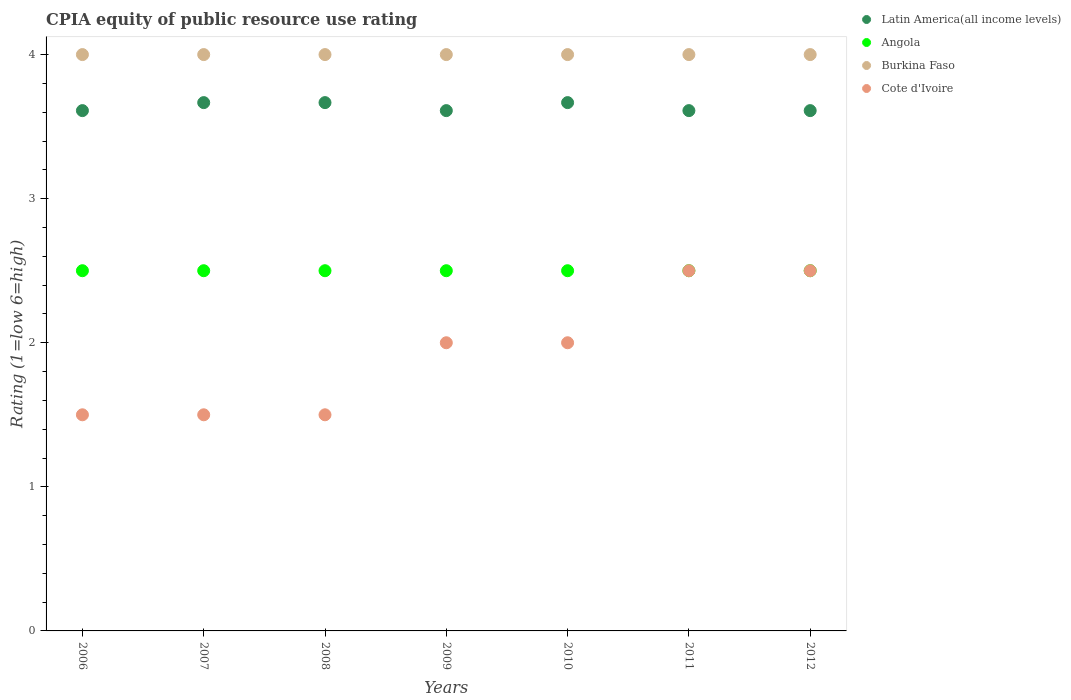Is the number of dotlines equal to the number of legend labels?
Ensure brevity in your answer.  Yes. What is the CPIA rating in Burkina Faso in 2007?
Offer a terse response. 4. Across all years, what is the maximum CPIA rating in Burkina Faso?
Your answer should be very brief. 4. Across all years, what is the minimum CPIA rating in Angola?
Offer a very short reply. 2.5. In which year was the CPIA rating in Angola maximum?
Give a very brief answer. 2006. In which year was the CPIA rating in Cote d'Ivoire minimum?
Give a very brief answer. 2006. What is the total CPIA rating in Burkina Faso in the graph?
Offer a very short reply. 28. What is the difference between the CPIA rating in Latin America(all income levels) in 2009 and that in 2010?
Ensure brevity in your answer.  -0.06. What is the difference between the CPIA rating in Cote d'Ivoire in 2011 and the CPIA rating in Latin America(all income levels) in 2008?
Offer a terse response. -1.17. What is the average CPIA rating in Cote d'Ivoire per year?
Ensure brevity in your answer.  1.93. In the year 2011, what is the difference between the CPIA rating in Latin America(all income levels) and CPIA rating in Cote d'Ivoire?
Your response must be concise. 1.11. In how many years, is the CPIA rating in Angola greater than 3?
Your answer should be compact. 0. Is the CPIA rating in Latin America(all income levels) in 2009 less than that in 2010?
Ensure brevity in your answer.  Yes. Is the difference between the CPIA rating in Latin America(all income levels) in 2007 and 2012 greater than the difference between the CPIA rating in Cote d'Ivoire in 2007 and 2012?
Make the answer very short. Yes. What is the difference between the highest and the second highest CPIA rating in Burkina Faso?
Your response must be concise. 0. What is the difference between the highest and the lowest CPIA rating in Latin America(all income levels)?
Your answer should be compact. 0.06. Is the sum of the CPIA rating in Angola in 2007 and 2009 greater than the maximum CPIA rating in Latin America(all income levels) across all years?
Your answer should be compact. Yes. Is it the case that in every year, the sum of the CPIA rating in Latin America(all income levels) and CPIA rating in Cote d'Ivoire  is greater than the sum of CPIA rating in Burkina Faso and CPIA rating in Angola?
Ensure brevity in your answer.  Yes. Is it the case that in every year, the sum of the CPIA rating in Latin America(all income levels) and CPIA rating in Angola  is greater than the CPIA rating in Cote d'Ivoire?
Make the answer very short. Yes. Does the CPIA rating in Cote d'Ivoire monotonically increase over the years?
Offer a very short reply. No. Is the CPIA rating in Latin America(all income levels) strictly less than the CPIA rating in Burkina Faso over the years?
Ensure brevity in your answer.  Yes. Does the graph contain grids?
Give a very brief answer. No. Where does the legend appear in the graph?
Give a very brief answer. Top right. What is the title of the graph?
Keep it short and to the point. CPIA equity of public resource use rating. What is the label or title of the X-axis?
Offer a terse response. Years. What is the Rating (1=low 6=high) in Latin America(all income levels) in 2006?
Offer a very short reply. 3.61. What is the Rating (1=low 6=high) in Angola in 2006?
Offer a terse response. 2.5. What is the Rating (1=low 6=high) in Burkina Faso in 2006?
Your response must be concise. 4. What is the Rating (1=low 6=high) of Cote d'Ivoire in 2006?
Offer a terse response. 1.5. What is the Rating (1=low 6=high) in Latin America(all income levels) in 2007?
Keep it short and to the point. 3.67. What is the Rating (1=low 6=high) of Angola in 2007?
Your answer should be very brief. 2.5. What is the Rating (1=low 6=high) of Burkina Faso in 2007?
Provide a short and direct response. 4. What is the Rating (1=low 6=high) in Cote d'Ivoire in 2007?
Provide a short and direct response. 1.5. What is the Rating (1=low 6=high) in Latin America(all income levels) in 2008?
Offer a terse response. 3.67. What is the Rating (1=low 6=high) of Angola in 2008?
Offer a terse response. 2.5. What is the Rating (1=low 6=high) of Latin America(all income levels) in 2009?
Make the answer very short. 3.61. What is the Rating (1=low 6=high) of Burkina Faso in 2009?
Give a very brief answer. 4. What is the Rating (1=low 6=high) of Cote d'Ivoire in 2009?
Give a very brief answer. 2. What is the Rating (1=low 6=high) of Latin America(all income levels) in 2010?
Offer a very short reply. 3.67. What is the Rating (1=low 6=high) of Burkina Faso in 2010?
Your answer should be compact. 4. What is the Rating (1=low 6=high) of Cote d'Ivoire in 2010?
Offer a terse response. 2. What is the Rating (1=low 6=high) of Latin America(all income levels) in 2011?
Offer a very short reply. 3.61. What is the Rating (1=low 6=high) in Latin America(all income levels) in 2012?
Your answer should be very brief. 3.61. What is the Rating (1=low 6=high) of Cote d'Ivoire in 2012?
Keep it short and to the point. 2.5. Across all years, what is the maximum Rating (1=low 6=high) in Latin America(all income levels)?
Make the answer very short. 3.67. Across all years, what is the maximum Rating (1=low 6=high) of Angola?
Your answer should be compact. 2.5. Across all years, what is the minimum Rating (1=low 6=high) of Latin America(all income levels)?
Give a very brief answer. 3.61. Across all years, what is the minimum Rating (1=low 6=high) of Angola?
Provide a succinct answer. 2.5. What is the total Rating (1=low 6=high) of Latin America(all income levels) in the graph?
Ensure brevity in your answer.  25.44. What is the total Rating (1=low 6=high) in Burkina Faso in the graph?
Ensure brevity in your answer.  28. What is the difference between the Rating (1=low 6=high) of Latin America(all income levels) in 2006 and that in 2007?
Make the answer very short. -0.06. What is the difference between the Rating (1=low 6=high) of Burkina Faso in 2006 and that in 2007?
Ensure brevity in your answer.  0. What is the difference between the Rating (1=low 6=high) in Cote d'Ivoire in 2006 and that in 2007?
Give a very brief answer. 0. What is the difference between the Rating (1=low 6=high) of Latin America(all income levels) in 2006 and that in 2008?
Provide a succinct answer. -0.06. What is the difference between the Rating (1=low 6=high) of Burkina Faso in 2006 and that in 2008?
Your answer should be very brief. 0. What is the difference between the Rating (1=low 6=high) of Cote d'Ivoire in 2006 and that in 2008?
Make the answer very short. 0. What is the difference between the Rating (1=low 6=high) of Angola in 2006 and that in 2009?
Your answer should be compact. 0. What is the difference between the Rating (1=low 6=high) in Cote d'Ivoire in 2006 and that in 2009?
Keep it short and to the point. -0.5. What is the difference between the Rating (1=low 6=high) in Latin America(all income levels) in 2006 and that in 2010?
Make the answer very short. -0.06. What is the difference between the Rating (1=low 6=high) in Angola in 2006 and that in 2010?
Ensure brevity in your answer.  0. What is the difference between the Rating (1=low 6=high) in Burkina Faso in 2006 and that in 2010?
Your response must be concise. 0. What is the difference between the Rating (1=low 6=high) of Angola in 2006 and that in 2011?
Keep it short and to the point. 0. What is the difference between the Rating (1=low 6=high) in Burkina Faso in 2006 and that in 2011?
Your answer should be compact. 0. What is the difference between the Rating (1=low 6=high) of Cote d'Ivoire in 2006 and that in 2011?
Provide a succinct answer. -1. What is the difference between the Rating (1=low 6=high) in Latin America(all income levels) in 2006 and that in 2012?
Ensure brevity in your answer.  0. What is the difference between the Rating (1=low 6=high) in Angola in 2006 and that in 2012?
Give a very brief answer. 0. What is the difference between the Rating (1=low 6=high) in Latin America(all income levels) in 2007 and that in 2009?
Offer a very short reply. 0.06. What is the difference between the Rating (1=low 6=high) in Angola in 2007 and that in 2009?
Give a very brief answer. 0. What is the difference between the Rating (1=low 6=high) in Burkina Faso in 2007 and that in 2009?
Your answer should be very brief. 0. What is the difference between the Rating (1=low 6=high) of Latin America(all income levels) in 2007 and that in 2010?
Make the answer very short. 0. What is the difference between the Rating (1=low 6=high) in Latin America(all income levels) in 2007 and that in 2011?
Your answer should be compact. 0.06. What is the difference between the Rating (1=low 6=high) of Latin America(all income levels) in 2007 and that in 2012?
Ensure brevity in your answer.  0.06. What is the difference between the Rating (1=low 6=high) of Angola in 2007 and that in 2012?
Your answer should be very brief. 0. What is the difference between the Rating (1=low 6=high) of Latin America(all income levels) in 2008 and that in 2009?
Keep it short and to the point. 0.06. What is the difference between the Rating (1=low 6=high) of Cote d'Ivoire in 2008 and that in 2010?
Offer a very short reply. -0.5. What is the difference between the Rating (1=low 6=high) in Latin America(all income levels) in 2008 and that in 2011?
Offer a very short reply. 0.06. What is the difference between the Rating (1=low 6=high) in Angola in 2008 and that in 2011?
Offer a terse response. 0. What is the difference between the Rating (1=low 6=high) in Latin America(all income levels) in 2008 and that in 2012?
Your answer should be very brief. 0.06. What is the difference between the Rating (1=low 6=high) in Angola in 2008 and that in 2012?
Provide a succinct answer. 0. What is the difference between the Rating (1=low 6=high) in Burkina Faso in 2008 and that in 2012?
Provide a succinct answer. 0. What is the difference between the Rating (1=low 6=high) of Cote d'Ivoire in 2008 and that in 2012?
Your response must be concise. -1. What is the difference between the Rating (1=low 6=high) in Latin America(all income levels) in 2009 and that in 2010?
Keep it short and to the point. -0.06. What is the difference between the Rating (1=low 6=high) of Burkina Faso in 2009 and that in 2010?
Provide a short and direct response. 0. What is the difference between the Rating (1=low 6=high) in Latin America(all income levels) in 2009 and that in 2011?
Give a very brief answer. 0. What is the difference between the Rating (1=low 6=high) of Angola in 2009 and that in 2011?
Ensure brevity in your answer.  0. What is the difference between the Rating (1=low 6=high) in Cote d'Ivoire in 2009 and that in 2011?
Offer a terse response. -0.5. What is the difference between the Rating (1=low 6=high) in Latin America(all income levels) in 2009 and that in 2012?
Your answer should be compact. 0. What is the difference between the Rating (1=low 6=high) of Angola in 2009 and that in 2012?
Make the answer very short. 0. What is the difference between the Rating (1=low 6=high) of Latin America(all income levels) in 2010 and that in 2011?
Make the answer very short. 0.06. What is the difference between the Rating (1=low 6=high) in Angola in 2010 and that in 2011?
Your response must be concise. 0. What is the difference between the Rating (1=low 6=high) of Burkina Faso in 2010 and that in 2011?
Give a very brief answer. 0. What is the difference between the Rating (1=low 6=high) in Cote d'Ivoire in 2010 and that in 2011?
Make the answer very short. -0.5. What is the difference between the Rating (1=low 6=high) in Latin America(all income levels) in 2010 and that in 2012?
Provide a short and direct response. 0.06. What is the difference between the Rating (1=low 6=high) of Burkina Faso in 2010 and that in 2012?
Keep it short and to the point. 0. What is the difference between the Rating (1=low 6=high) in Cote d'Ivoire in 2010 and that in 2012?
Offer a terse response. -0.5. What is the difference between the Rating (1=low 6=high) in Latin America(all income levels) in 2011 and that in 2012?
Your answer should be compact. 0. What is the difference between the Rating (1=low 6=high) in Angola in 2011 and that in 2012?
Keep it short and to the point. 0. What is the difference between the Rating (1=low 6=high) in Burkina Faso in 2011 and that in 2012?
Provide a succinct answer. 0. What is the difference between the Rating (1=low 6=high) in Latin America(all income levels) in 2006 and the Rating (1=low 6=high) in Burkina Faso in 2007?
Offer a very short reply. -0.39. What is the difference between the Rating (1=low 6=high) of Latin America(all income levels) in 2006 and the Rating (1=low 6=high) of Cote d'Ivoire in 2007?
Your response must be concise. 2.11. What is the difference between the Rating (1=low 6=high) in Angola in 2006 and the Rating (1=low 6=high) in Burkina Faso in 2007?
Ensure brevity in your answer.  -1.5. What is the difference between the Rating (1=low 6=high) in Angola in 2006 and the Rating (1=low 6=high) in Cote d'Ivoire in 2007?
Your answer should be compact. 1. What is the difference between the Rating (1=low 6=high) of Latin America(all income levels) in 2006 and the Rating (1=low 6=high) of Burkina Faso in 2008?
Ensure brevity in your answer.  -0.39. What is the difference between the Rating (1=low 6=high) in Latin America(all income levels) in 2006 and the Rating (1=low 6=high) in Cote d'Ivoire in 2008?
Provide a succinct answer. 2.11. What is the difference between the Rating (1=low 6=high) of Angola in 2006 and the Rating (1=low 6=high) of Cote d'Ivoire in 2008?
Offer a very short reply. 1. What is the difference between the Rating (1=low 6=high) of Latin America(all income levels) in 2006 and the Rating (1=low 6=high) of Angola in 2009?
Your answer should be compact. 1.11. What is the difference between the Rating (1=low 6=high) in Latin America(all income levels) in 2006 and the Rating (1=low 6=high) in Burkina Faso in 2009?
Your answer should be compact. -0.39. What is the difference between the Rating (1=low 6=high) in Latin America(all income levels) in 2006 and the Rating (1=low 6=high) in Cote d'Ivoire in 2009?
Provide a succinct answer. 1.61. What is the difference between the Rating (1=low 6=high) in Angola in 2006 and the Rating (1=low 6=high) in Cote d'Ivoire in 2009?
Your response must be concise. 0.5. What is the difference between the Rating (1=low 6=high) of Latin America(all income levels) in 2006 and the Rating (1=low 6=high) of Burkina Faso in 2010?
Keep it short and to the point. -0.39. What is the difference between the Rating (1=low 6=high) of Latin America(all income levels) in 2006 and the Rating (1=low 6=high) of Cote d'Ivoire in 2010?
Ensure brevity in your answer.  1.61. What is the difference between the Rating (1=low 6=high) of Angola in 2006 and the Rating (1=low 6=high) of Burkina Faso in 2010?
Your answer should be compact. -1.5. What is the difference between the Rating (1=low 6=high) of Angola in 2006 and the Rating (1=low 6=high) of Cote d'Ivoire in 2010?
Ensure brevity in your answer.  0.5. What is the difference between the Rating (1=low 6=high) in Burkina Faso in 2006 and the Rating (1=low 6=high) in Cote d'Ivoire in 2010?
Give a very brief answer. 2. What is the difference between the Rating (1=low 6=high) in Latin America(all income levels) in 2006 and the Rating (1=low 6=high) in Burkina Faso in 2011?
Your answer should be very brief. -0.39. What is the difference between the Rating (1=low 6=high) of Latin America(all income levels) in 2006 and the Rating (1=low 6=high) of Cote d'Ivoire in 2011?
Provide a succinct answer. 1.11. What is the difference between the Rating (1=low 6=high) of Angola in 2006 and the Rating (1=low 6=high) of Cote d'Ivoire in 2011?
Make the answer very short. 0. What is the difference between the Rating (1=low 6=high) in Latin America(all income levels) in 2006 and the Rating (1=low 6=high) in Burkina Faso in 2012?
Give a very brief answer. -0.39. What is the difference between the Rating (1=low 6=high) of Angola in 2006 and the Rating (1=low 6=high) of Burkina Faso in 2012?
Your answer should be compact. -1.5. What is the difference between the Rating (1=low 6=high) in Angola in 2006 and the Rating (1=low 6=high) in Cote d'Ivoire in 2012?
Your answer should be very brief. 0. What is the difference between the Rating (1=low 6=high) in Burkina Faso in 2006 and the Rating (1=low 6=high) in Cote d'Ivoire in 2012?
Provide a succinct answer. 1.5. What is the difference between the Rating (1=low 6=high) of Latin America(all income levels) in 2007 and the Rating (1=low 6=high) of Burkina Faso in 2008?
Your response must be concise. -0.33. What is the difference between the Rating (1=low 6=high) of Latin America(all income levels) in 2007 and the Rating (1=low 6=high) of Cote d'Ivoire in 2008?
Give a very brief answer. 2.17. What is the difference between the Rating (1=low 6=high) in Angola in 2007 and the Rating (1=low 6=high) in Burkina Faso in 2008?
Provide a succinct answer. -1.5. What is the difference between the Rating (1=low 6=high) in Latin America(all income levels) in 2007 and the Rating (1=low 6=high) in Angola in 2009?
Make the answer very short. 1.17. What is the difference between the Rating (1=low 6=high) in Angola in 2007 and the Rating (1=low 6=high) in Burkina Faso in 2009?
Provide a succinct answer. -1.5. What is the difference between the Rating (1=low 6=high) of Angola in 2007 and the Rating (1=low 6=high) of Cote d'Ivoire in 2009?
Your response must be concise. 0.5. What is the difference between the Rating (1=low 6=high) of Burkina Faso in 2007 and the Rating (1=low 6=high) of Cote d'Ivoire in 2009?
Offer a very short reply. 2. What is the difference between the Rating (1=low 6=high) of Angola in 2007 and the Rating (1=low 6=high) of Cote d'Ivoire in 2010?
Your response must be concise. 0.5. What is the difference between the Rating (1=low 6=high) of Burkina Faso in 2007 and the Rating (1=low 6=high) of Cote d'Ivoire in 2010?
Your answer should be very brief. 2. What is the difference between the Rating (1=low 6=high) of Latin America(all income levels) in 2007 and the Rating (1=low 6=high) of Angola in 2011?
Make the answer very short. 1.17. What is the difference between the Rating (1=low 6=high) in Latin America(all income levels) in 2007 and the Rating (1=low 6=high) in Burkina Faso in 2011?
Make the answer very short. -0.33. What is the difference between the Rating (1=low 6=high) of Angola in 2007 and the Rating (1=low 6=high) of Burkina Faso in 2011?
Keep it short and to the point. -1.5. What is the difference between the Rating (1=low 6=high) in Latin America(all income levels) in 2007 and the Rating (1=low 6=high) in Angola in 2012?
Make the answer very short. 1.17. What is the difference between the Rating (1=low 6=high) in Latin America(all income levels) in 2007 and the Rating (1=low 6=high) in Burkina Faso in 2012?
Give a very brief answer. -0.33. What is the difference between the Rating (1=low 6=high) in Latin America(all income levels) in 2007 and the Rating (1=low 6=high) in Cote d'Ivoire in 2012?
Your answer should be compact. 1.17. What is the difference between the Rating (1=low 6=high) of Angola in 2007 and the Rating (1=low 6=high) of Cote d'Ivoire in 2012?
Your response must be concise. 0. What is the difference between the Rating (1=low 6=high) of Latin America(all income levels) in 2008 and the Rating (1=low 6=high) of Angola in 2009?
Your answer should be compact. 1.17. What is the difference between the Rating (1=low 6=high) of Latin America(all income levels) in 2008 and the Rating (1=low 6=high) of Cote d'Ivoire in 2009?
Ensure brevity in your answer.  1.67. What is the difference between the Rating (1=low 6=high) of Angola in 2008 and the Rating (1=low 6=high) of Burkina Faso in 2009?
Make the answer very short. -1.5. What is the difference between the Rating (1=low 6=high) of Angola in 2008 and the Rating (1=low 6=high) of Cote d'Ivoire in 2009?
Give a very brief answer. 0.5. What is the difference between the Rating (1=low 6=high) of Burkina Faso in 2008 and the Rating (1=low 6=high) of Cote d'Ivoire in 2009?
Keep it short and to the point. 2. What is the difference between the Rating (1=low 6=high) of Latin America(all income levels) in 2008 and the Rating (1=low 6=high) of Angola in 2011?
Ensure brevity in your answer.  1.17. What is the difference between the Rating (1=low 6=high) of Latin America(all income levels) in 2008 and the Rating (1=low 6=high) of Burkina Faso in 2011?
Your answer should be very brief. -0.33. What is the difference between the Rating (1=low 6=high) of Latin America(all income levels) in 2008 and the Rating (1=low 6=high) of Cote d'Ivoire in 2011?
Your answer should be compact. 1.17. What is the difference between the Rating (1=low 6=high) in Angola in 2008 and the Rating (1=low 6=high) in Burkina Faso in 2011?
Offer a terse response. -1.5. What is the difference between the Rating (1=low 6=high) in Angola in 2008 and the Rating (1=low 6=high) in Cote d'Ivoire in 2011?
Your answer should be very brief. 0. What is the difference between the Rating (1=low 6=high) in Burkina Faso in 2008 and the Rating (1=low 6=high) in Cote d'Ivoire in 2011?
Provide a succinct answer. 1.5. What is the difference between the Rating (1=low 6=high) in Latin America(all income levels) in 2008 and the Rating (1=low 6=high) in Angola in 2012?
Offer a very short reply. 1.17. What is the difference between the Rating (1=low 6=high) in Angola in 2008 and the Rating (1=low 6=high) in Burkina Faso in 2012?
Provide a short and direct response. -1.5. What is the difference between the Rating (1=low 6=high) of Angola in 2008 and the Rating (1=low 6=high) of Cote d'Ivoire in 2012?
Make the answer very short. 0. What is the difference between the Rating (1=low 6=high) of Burkina Faso in 2008 and the Rating (1=low 6=high) of Cote d'Ivoire in 2012?
Your answer should be very brief. 1.5. What is the difference between the Rating (1=low 6=high) of Latin America(all income levels) in 2009 and the Rating (1=low 6=high) of Burkina Faso in 2010?
Provide a succinct answer. -0.39. What is the difference between the Rating (1=low 6=high) in Latin America(all income levels) in 2009 and the Rating (1=low 6=high) in Cote d'Ivoire in 2010?
Offer a terse response. 1.61. What is the difference between the Rating (1=low 6=high) in Angola in 2009 and the Rating (1=low 6=high) in Cote d'Ivoire in 2010?
Offer a very short reply. 0.5. What is the difference between the Rating (1=low 6=high) of Burkina Faso in 2009 and the Rating (1=low 6=high) of Cote d'Ivoire in 2010?
Offer a very short reply. 2. What is the difference between the Rating (1=low 6=high) of Latin America(all income levels) in 2009 and the Rating (1=low 6=high) of Angola in 2011?
Provide a short and direct response. 1.11. What is the difference between the Rating (1=low 6=high) in Latin America(all income levels) in 2009 and the Rating (1=low 6=high) in Burkina Faso in 2011?
Your answer should be very brief. -0.39. What is the difference between the Rating (1=low 6=high) in Latin America(all income levels) in 2009 and the Rating (1=low 6=high) in Cote d'Ivoire in 2011?
Ensure brevity in your answer.  1.11. What is the difference between the Rating (1=low 6=high) in Angola in 2009 and the Rating (1=low 6=high) in Cote d'Ivoire in 2011?
Provide a short and direct response. 0. What is the difference between the Rating (1=low 6=high) of Burkina Faso in 2009 and the Rating (1=low 6=high) of Cote d'Ivoire in 2011?
Offer a terse response. 1.5. What is the difference between the Rating (1=low 6=high) of Latin America(all income levels) in 2009 and the Rating (1=low 6=high) of Burkina Faso in 2012?
Offer a very short reply. -0.39. What is the difference between the Rating (1=low 6=high) in Latin America(all income levels) in 2009 and the Rating (1=low 6=high) in Cote d'Ivoire in 2012?
Give a very brief answer. 1.11. What is the difference between the Rating (1=low 6=high) of Angola in 2009 and the Rating (1=low 6=high) of Burkina Faso in 2012?
Your answer should be very brief. -1.5. What is the difference between the Rating (1=low 6=high) in Angola in 2009 and the Rating (1=low 6=high) in Cote d'Ivoire in 2012?
Offer a terse response. 0. What is the difference between the Rating (1=low 6=high) of Latin America(all income levels) in 2010 and the Rating (1=low 6=high) of Cote d'Ivoire in 2011?
Offer a terse response. 1.17. What is the difference between the Rating (1=low 6=high) in Angola in 2010 and the Rating (1=low 6=high) in Burkina Faso in 2011?
Your response must be concise. -1.5. What is the difference between the Rating (1=low 6=high) of Angola in 2010 and the Rating (1=low 6=high) of Cote d'Ivoire in 2011?
Provide a short and direct response. 0. What is the difference between the Rating (1=low 6=high) of Latin America(all income levels) in 2010 and the Rating (1=low 6=high) of Burkina Faso in 2012?
Your answer should be compact. -0.33. What is the difference between the Rating (1=low 6=high) of Latin America(all income levels) in 2010 and the Rating (1=low 6=high) of Cote d'Ivoire in 2012?
Offer a very short reply. 1.17. What is the difference between the Rating (1=low 6=high) in Angola in 2010 and the Rating (1=low 6=high) in Burkina Faso in 2012?
Ensure brevity in your answer.  -1.5. What is the difference between the Rating (1=low 6=high) of Burkina Faso in 2010 and the Rating (1=low 6=high) of Cote d'Ivoire in 2012?
Offer a very short reply. 1.5. What is the difference between the Rating (1=low 6=high) of Latin America(all income levels) in 2011 and the Rating (1=low 6=high) of Burkina Faso in 2012?
Offer a terse response. -0.39. What is the difference between the Rating (1=low 6=high) of Latin America(all income levels) in 2011 and the Rating (1=low 6=high) of Cote d'Ivoire in 2012?
Keep it short and to the point. 1.11. What is the difference between the Rating (1=low 6=high) in Burkina Faso in 2011 and the Rating (1=low 6=high) in Cote d'Ivoire in 2012?
Provide a succinct answer. 1.5. What is the average Rating (1=low 6=high) in Latin America(all income levels) per year?
Your answer should be very brief. 3.63. What is the average Rating (1=low 6=high) of Angola per year?
Offer a terse response. 2.5. What is the average Rating (1=low 6=high) in Cote d'Ivoire per year?
Give a very brief answer. 1.93. In the year 2006, what is the difference between the Rating (1=low 6=high) of Latin America(all income levels) and Rating (1=low 6=high) of Angola?
Make the answer very short. 1.11. In the year 2006, what is the difference between the Rating (1=low 6=high) in Latin America(all income levels) and Rating (1=low 6=high) in Burkina Faso?
Your response must be concise. -0.39. In the year 2006, what is the difference between the Rating (1=low 6=high) in Latin America(all income levels) and Rating (1=low 6=high) in Cote d'Ivoire?
Offer a terse response. 2.11. In the year 2006, what is the difference between the Rating (1=low 6=high) of Angola and Rating (1=low 6=high) of Cote d'Ivoire?
Keep it short and to the point. 1. In the year 2006, what is the difference between the Rating (1=low 6=high) in Burkina Faso and Rating (1=low 6=high) in Cote d'Ivoire?
Your answer should be very brief. 2.5. In the year 2007, what is the difference between the Rating (1=low 6=high) in Latin America(all income levels) and Rating (1=low 6=high) in Cote d'Ivoire?
Provide a short and direct response. 2.17. In the year 2007, what is the difference between the Rating (1=low 6=high) of Angola and Rating (1=low 6=high) of Cote d'Ivoire?
Provide a succinct answer. 1. In the year 2008, what is the difference between the Rating (1=low 6=high) of Latin America(all income levels) and Rating (1=low 6=high) of Angola?
Offer a very short reply. 1.17. In the year 2008, what is the difference between the Rating (1=low 6=high) of Latin America(all income levels) and Rating (1=low 6=high) of Cote d'Ivoire?
Provide a short and direct response. 2.17. In the year 2009, what is the difference between the Rating (1=low 6=high) in Latin America(all income levels) and Rating (1=low 6=high) in Burkina Faso?
Your answer should be very brief. -0.39. In the year 2009, what is the difference between the Rating (1=low 6=high) of Latin America(all income levels) and Rating (1=low 6=high) of Cote d'Ivoire?
Keep it short and to the point. 1.61. In the year 2009, what is the difference between the Rating (1=low 6=high) in Angola and Rating (1=low 6=high) in Burkina Faso?
Your response must be concise. -1.5. In the year 2009, what is the difference between the Rating (1=low 6=high) of Angola and Rating (1=low 6=high) of Cote d'Ivoire?
Offer a very short reply. 0.5. In the year 2010, what is the difference between the Rating (1=low 6=high) of Latin America(all income levels) and Rating (1=low 6=high) of Burkina Faso?
Make the answer very short. -0.33. In the year 2010, what is the difference between the Rating (1=low 6=high) in Latin America(all income levels) and Rating (1=low 6=high) in Cote d'Ivoire?
Provide a short and direct response. 1.67. In the year 2010, what is the difference between the Rating (1=low 6=high) in Burkina Faso and Rating (1=low 6=high) in Cote d'Ivoire?
Keep it short and to the point. 2. In the year 2011, what is the difference between the Rating (1=low 6=high) in Latin America(all income levels) and Rating (1=low 6=high) in Angola?
Offer a terse response. 1.11. In the year 2011, what is the difference between the Rating (1=low 6=high) of Latin America(all income levels) and Rating (1=low 6=high) of Burkina Faso?
Keep it short and to the point. -0.39. In the year 2011, what is the difference between the Rating (1=low 6=high) in Burkina Faso and Rating (1=low 6=high) in Cote d'Ivoire?
Ensure brevity in your answer.  1.5. In the year 2012, what is the difference between the Rating (1=low 6=high) in Latin America(all income levels) and Rating (1=low 6=high) in Burkina Faso?
Your response must be concise. -0.39. In the year 2012, what is the difference between the Rating (1=low 6=high) of Latin America(all income levels) and Rating (1=low 6=high) of Cote d'Ivoire?
Make the answer very short. 1.11. In the year 2012, what is the difference between the Rating (1=low 6=high) of Angola and Rating (1=low 6=high) of Burkina Faso?
Your response must be concise. -1.5. In the year 2012, what is the difference between the Rating (1=low 6=high) in Angola and Rating (1=low 6=high) in Cote d'Ivoire?
Provide a short and direct response. 0. In the year 2012, what is the difference between the Rating (1=low 6=high) of Burkina Faso and Rating (1=low 6=high) of Cote d'Ivoire?
Your response must be concise. 1.5. What is the ratio of the Rating (1=low 6=high) in Burkina Faso in 2006 to that in 2007?
Offer a terse response. 1. What is the ratio of the Rating (1=low 6=high) of Cote d'Ivoire in 2006 to that in 2007?
Offer a terse response. 1. What is the ratio of the Rating (1=low 6=high) in Latin America(all income levels) in 2006 to that in 2008?
Your answer should be very brief. 0.98. What is the ratio of the Rating (1=low 6=high) of Angola in 2006 to that in 2008?
Your answer should be compact. 1. What is the ratio of the Rating (1=low 6=high) of Burkina Faso in 2006 to that in 2008?
Ensure brevity in your answer.  1. What is the ratio of the Rating (1=low 6=high) of Latin America(all income levels) in 2006 to that in 2009?
Give a very brief answer. 1. What is the ratio of the Rating (1=low 6=high) in Angola in 2006 to that in 2009?
Your answer should be compact. 1. What is the ratio of the Rating (1=low 6=high) of Burkina Faso in 2006 to that in 2009?
Offer a very short reply. 1. What is the ratio of the Rating (1=low 6=high) of Cote d'Ivoire in 2006 to that in 2009?
Make the answer very short. 0.75. What is the ratio of the Rating (1=low 6=high) in Latin America(all income levels) in 2006 to that in 2010?
Make the answer very short. 0.98. What is the ratio of the Rating (1=low 6=high) in Burkina Faso in 2006 to that in 2010?
Your answer should be very brief. 1. What is the ratio of the Rating (1=low 6=high) of Latin America(all income levels) in 2006 to that in 2011?
Keep it short and to the point. 1. What is the ratio of the Rating (1=low 6=high) of Angola in 2006 to that in 2011?
Keep it short and to the point. 1. What is the ratio of the Rating (1=low 6=high) in Cote d'Ivoire in 2006 to that in 2011?
Offer a terse response. 0.6. What is the ratio of the Rating (1=low 6=high) in Latin America(all income levels) in 2007 to that in 2008?
Keep it short and to the point. 1. What is the ratio of the Rating (1=low 6=high) of Burkina Faso in 2007 to that in 2008?
Offer a terse response. 1. What is the ratio of the Rating (1=low 6=high) of Latin America(all income levels) in 2007 to that in 2009?
Make the answer very short. 1.02. What is the ratio of the Rating (1=low 6=high) in Burkina Faso in 2007 to that in 2009?
Your response must be concise. 1. What is the ratio of the Rating (1=low 6=high) of Cote d'Ivoire in 2007 to that in 2009?
Ensure brevity in your answer.  0.75. What is the ratio of the Rating (1=low 6=high) in Burkina Faso in 2007 to that in 2010?
Make the answer very short. 1. What is the ratio of the Rating (1=low 6=high) of Cote d'Ivoire in 2007 to that in 2010?
Keep it short and to the point. 0.75. What is the ratio of the Rating (1=low 6=high) of Latin America(all income levels) in 2007 to that in 2011?
Provide a short and direct response. 1.02. What is the ratio of the Rating (1=low 6=high) in Latin America(all income levels) in 2007 to that in 2012?
Your response must be concise. 1.02. What is the ratio of the Rating (1=low 6=high) of Cote d'Ivoire in 2007 to that in 2012?
Ensure brevity in your answer.  0.6. What is the ratio of the Rating (1=low 6=high) in Latin America(all income levels) in 2008 to that in 2009?
Provide a short and direct response. 1.02. What is the ratio of the Rating (1=low 6=high) of Angola in 2008 to that in 2009?
Your answer should be very brief. 1. What is the ratio of the Rating (1=low 6=high) of Latin America(all income levels) in 2008 to that in 2010?
Provide a succinct answer. 1. What is the ratio of the Rating (1=low 6=high) in Angola in 2008 to that in 2010?
Keep it short and to the point. 1. What is the ratio of the Rating (1=low 6=high) in Cote d'Ivoire in 2008 to that in 2010?
Your response must be concise. 0.75. What is the ratio of the Rating (1=low 6=high) of Latin America(all income levels) in 2008 to that in 2011?
Make the answer very short. 1.02. What is the ratio of the Rating (1=low 6=high) of Angola in 2008 to that in 2011?
Your answer should be very brief. 1. What is the ratio of the Rating (1=low 6=high) in Burkina Faso in 2008 to that in 2011?
Offer a very short reply. 1. What is the ratio of the Rating (1=low 6=high) in Latin America(all income levels) in 2008 to that in 2012?
Ensure brevity in your answer.  1.02. What is the ratio of the Rating (1=low 6=high) in Angola in 2008 to that in 2012?
Provide a short and direct response. 1. What is the ratio of the Rating (1=low 6=high) in Cote d'Ivoire in 2008 to that in 2012?
Provide a succinct answer. 0.6. What is the ratio of the Rating (1=low 6=high) in Cote d'Ivoire in 2009 to that in 2010?
Your response must be concise. 1. What is the ratio of the Rating (1=low 6=high) of Latin America(all income levels) in 2009 to that in 2011?
Your answer should be very brief. 1. What is the ratio of the Rating (1=low 6=high) of Burkina Faso in 2009 to that in 2011?
Your answer should be very brief. 1. What is the ratio of the Rating (1=low 6=high) of Latin America(all income levels) in 2009 to that in 2012?
Give a very brief answer. 1. What is the ratio of the Rating (1=low 6=high) of Burkina Faso in 2009 to that in 2012?
Provide a succinct answer. 1. What is the ratio of the Rating (1=low 6=high) in Latin America(all income levels) in 2010 to that in 2011?
Offer a very short reply. 1.02. What is the ratio of the Rating (1=low 6=high) in Angola in 2010 to that in 2011?
Your answer should be very brief. 1. What is the ratio of the Rating (1=low 6=high) of Burkina Faso in 2010 to that in 2011?
Your response must be concise. 1. What is the ratio of the Rating (1=low 6=high) in Cote d'Ivoire in 2010 to that in 2011?
Provide a succinct answer. 0.8. What is the ratio of the Rating (1=low 6=high) of Latin America(all income levels) in 2010 to that in 2012?
Your answer should be compact. 1.02. What is the ratio of the Rating (1=low 6=high) in Angola in 2010 to that in 2012?
Your answer should be compact. 1. What is the ratio of the Rating (1=low 6=high) of Cote d'Ivoire in 2010 to that in 2012?
Your response must be concise. 0.8. What is the ratio of the Rating (1=low 6=high) of Latin America(all income levels) in 2011 to that in 2012?
Your answer should be compact. 1. What is the ratio of the Rating (1=low 6=high) of Burkina Faso in 2011 to that in 2012?
Your answer should be compact. 1. What is the ratio of the Rating (1=low 6=high) in Cote d'Ivoire in 2011 to that in 2012?
Provide a succinct answer. 1. What is the difference between the highest and the second highest Rating (1=low 6=high) in Angola?
Ensure brevity in your answer.  0. What is the difference between the highest and the second highest Rating (1=low 6=high) of Cote d'Ivoire?
Your answer should be very brief. 0. What is the difference between the highest and the lowest Rating (1=low 6=high) of Latin America(all income levels)?
Your answer should be very brief. 0.06. What is the difference between the highest and the lowest Rating (1=low 6=high) of Angola?
Your answer should be compact. 0. 